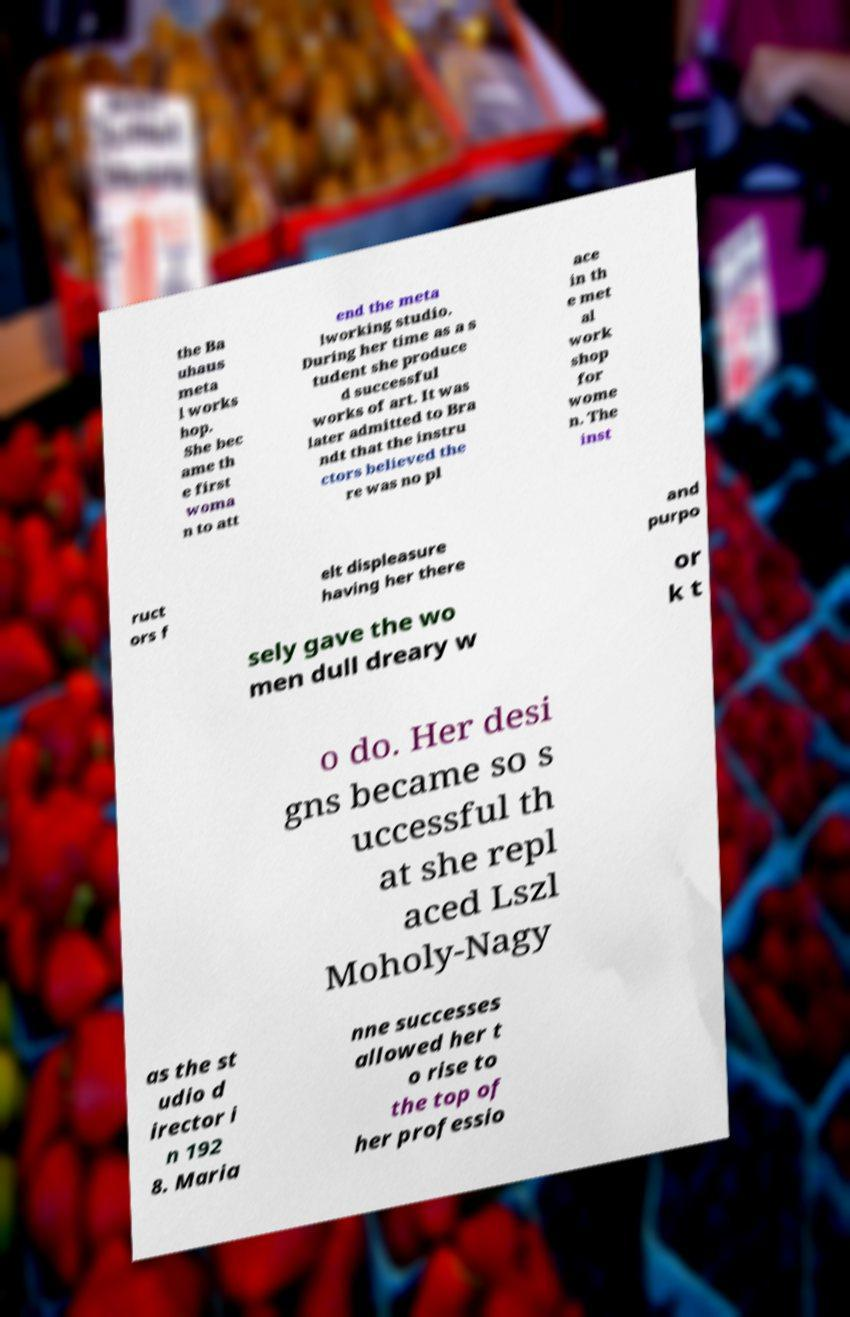For documentation purposes, I need the text within this image transcribed. Could you provide that? the Ba uhaus meta l works hop. She bec ame th e first woma n to att end the meta lworking studio. During her time as a s tudent she produce d successful works of art. It was later admitted to Bra ndt that the instru ctors believed the re was no pl ace in th e met al work shop for wome n. The inst ruct ors f elt displeasure having her there and purpo sely gave the wo men dull dreary w or k t o do. Her desi gns became so s uccessful th at she repl aced Lszl Moholy-Nagy as the st udio d irector i n 192 8. Maria nne successes allowed her t o rise to the top of her professio 